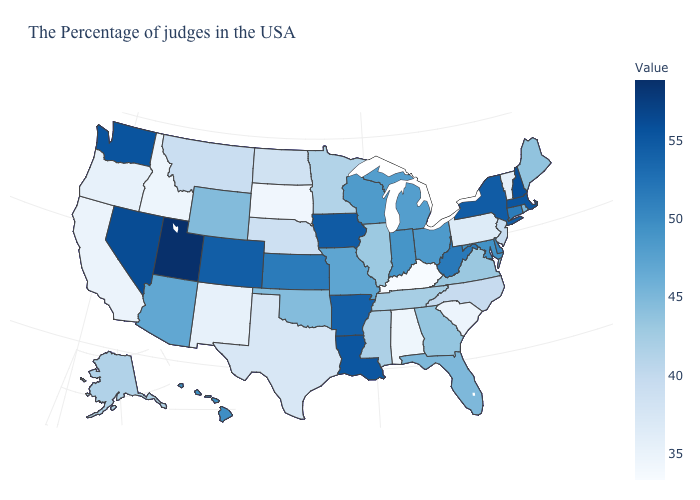Which states have the highest value in the USA?
Give a very brief answer. Utah. Among the states that border Illinois , does Wisconsin have the highest value?
Short answer required. No. Which states hav the highest value in the West?
Concise answer only. Utah. Which states have the lowest value in the USA?
Keep it brief. Kentucky. 